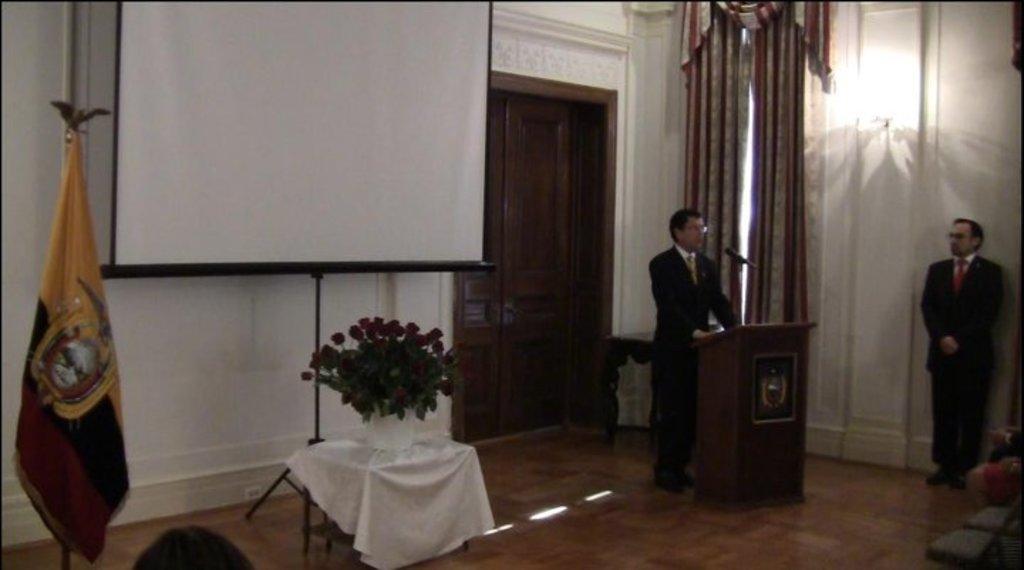Describe this image in one or two sentences. In this image we can see a projector screen. There is a flag at the left side of the image. A person is speaking into a microphone and standing near the podium. A person is standing at the right side of the image. We can see the legs of few people at the right side of the image. There is a light on the wall image. We can see the doors in the image. 